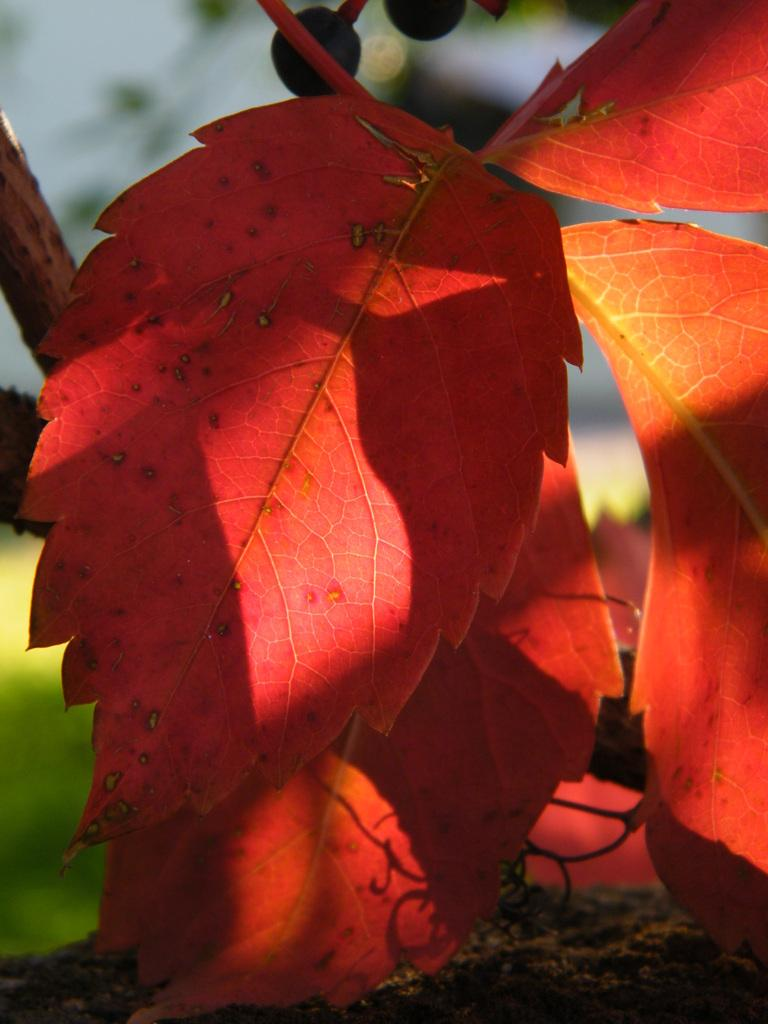What type of leaves can be seen in the foreground of the image? There are red color leaves in the foreground of the image. What else can be seen in the foreground of the image besides the leaves? There are other objects in the foreground of the image. How would you describe the background of the image? The background of the image is blurry. What can be seen in the background of the image besides the blurry scene? Soil is visible in the background of the image, along with other objects. What type of fuel is being used by the rock in the image? There is no rock present in the image, and therefore no fuel can be associated with it. 